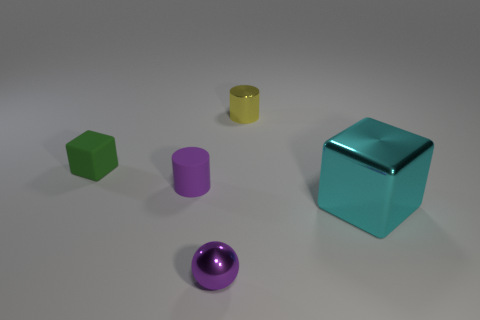There is another tiny thing that is the same shape as the yellow thing; what is its material?
Provide a succinct answer. Rubber. Are the block that is left of the small purple cylinder and the large cyan block made of the same material?
Keep it short and to the point. No. Are there more purple metal spheres behind the metal cylinder than metal things that are on the left side of the small matte cylinder?
Offer a terse response. No. What is the size of the purple rubber thing?
Offer a very short reply. Small. The purple object that is made of the same material as the cyan thing is what shape?
Offer a terse response. Sphere. There is a thing that is right of the tiny metallic cylinder; is its shape the same as the small yellow metallic object?
Your response must be concise. No. What number of objects are purple metallic balls or big cyan metallic blocks?
Your answer should be very brief. 2. What is the small thing that is both right of the purple matte cylinder and in front of the small yellow metallic object made of?
Offer a terse response. Metal. Does the ball have the same size as the green thing?
Your response must be concise. Yes. There is a metal object behind the cube that is in front of the tiny green matte thing; what size is it?
Offer a terse response. Small. 